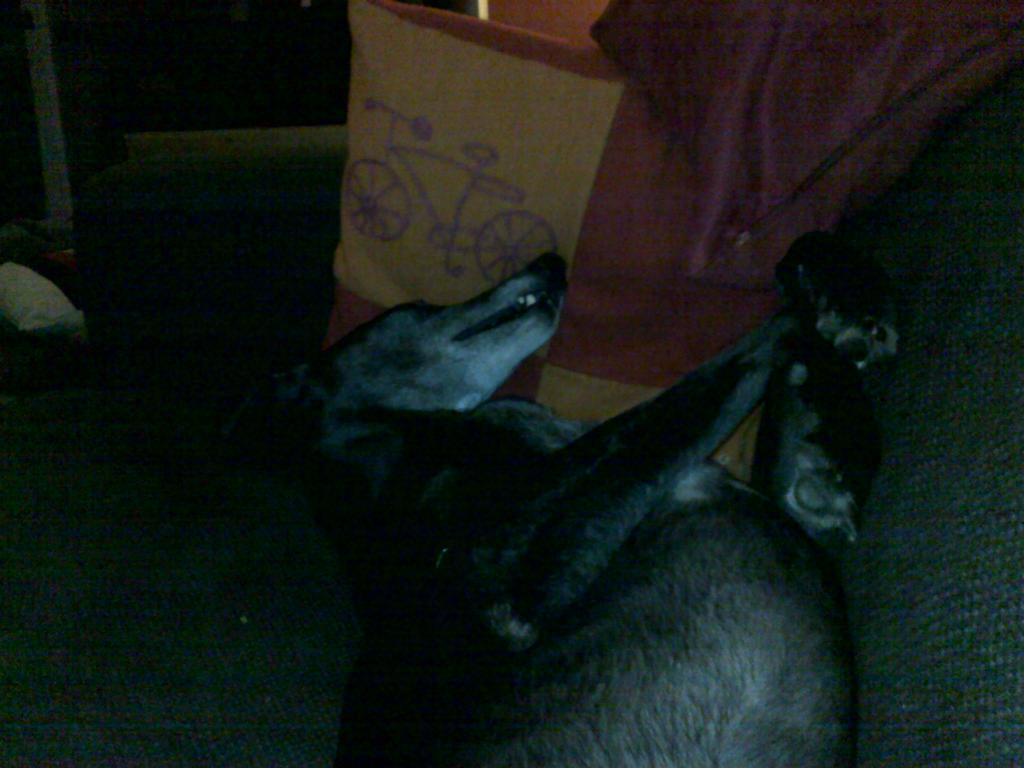Please provide a concise description of this image. There is a dog and there is a cover beside the dog,the dog is laying on its back. 